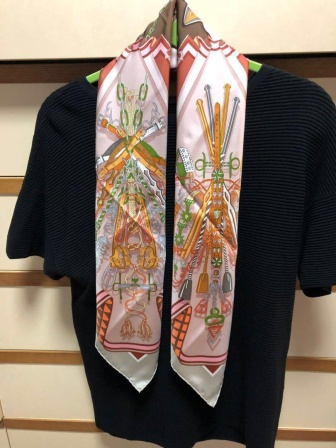How could this image be part of a fashion article? In the latest edition of 'Chic & Cozy,' a renowned fashion magazine, this image could feature prominently in an article titled 'Effortless Elegance: Master the Art of Layering.' The article would delve into how to combine simple wardrobe staples with statement accessories to create visually appealing outfits. The black sweater serves as a timeless base piece, while the vibrant scarf acts as the focal point, drawing attention and adding personality. Fashion experts would provide tips on color coordination, choosing the right textures, and balancing minimalism with bold accents. Readers would learn how to elevate their everyday looks with ease, making style both accessible and enjoyable. 